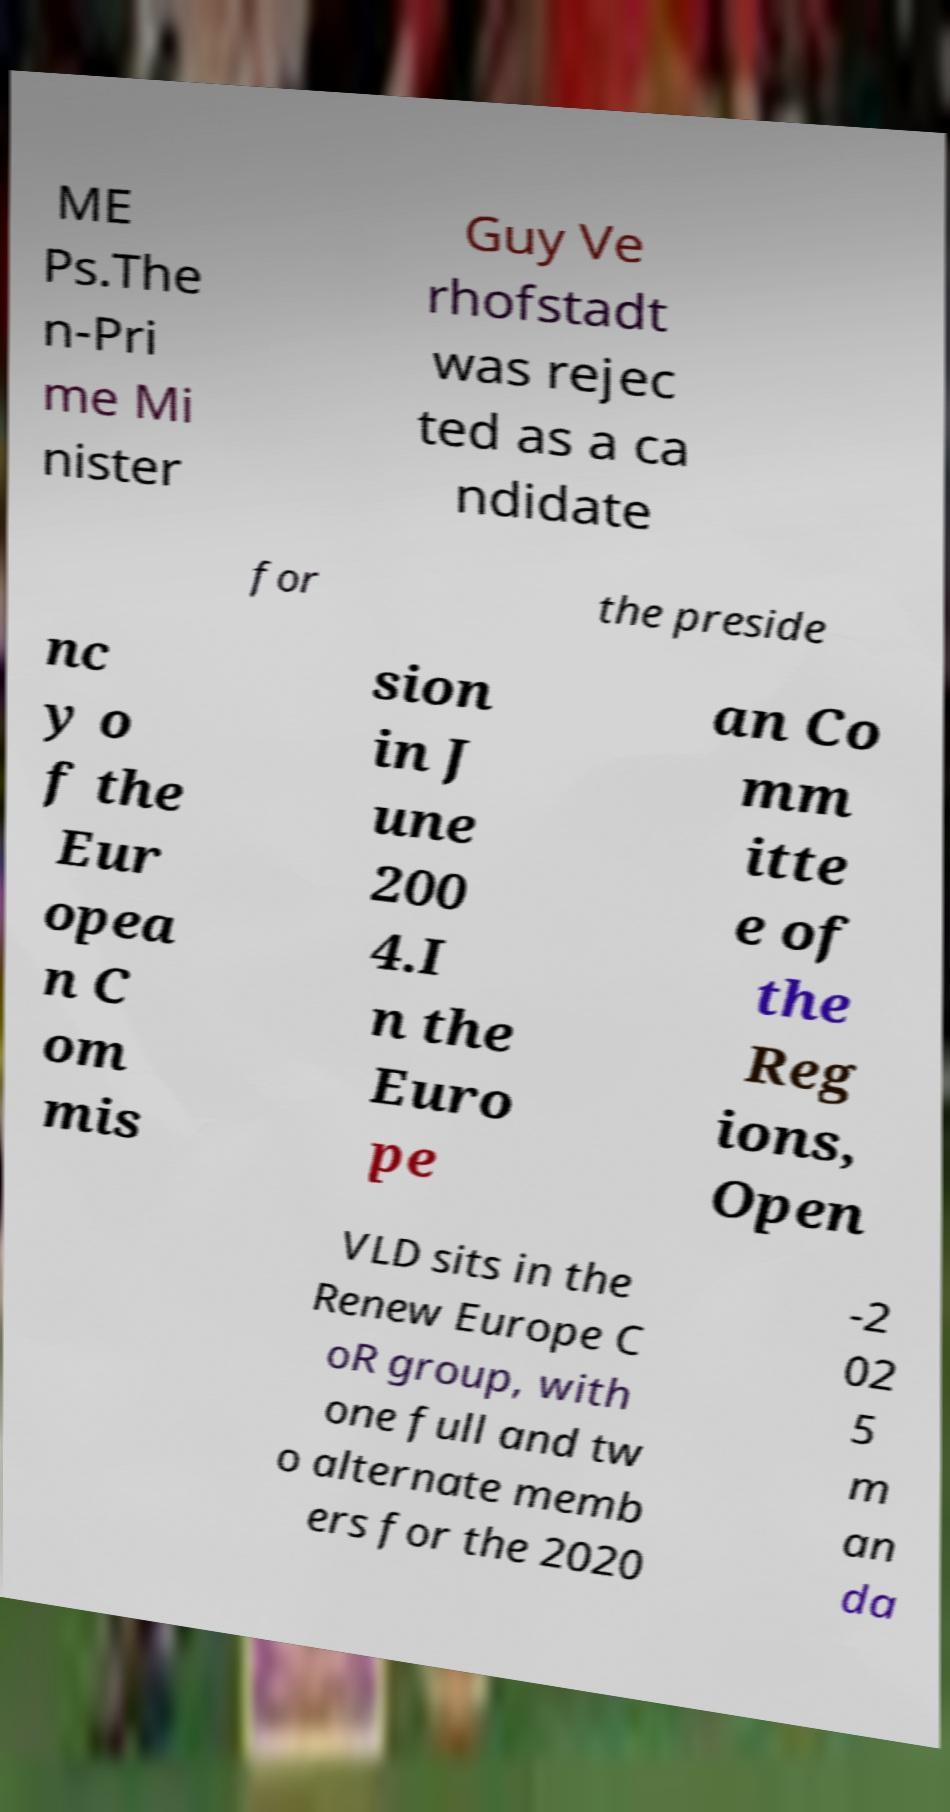Could you assist in decoding the text presented in this image and type it out clearly? ME Ps.The n-Pri me Mi nister Guy Ve rhofstadt was rejec ted as a ca ndidate for the preside nc y o f the Eur opea n C om mis sion in J une 200 4.I n the Euro pe an Co mm itte e of the Reg ions, Open VLD sits in the Renew Europe C oR group, with one full and tw o alternate memb ers for the 2020 -2 02 5 m an da 